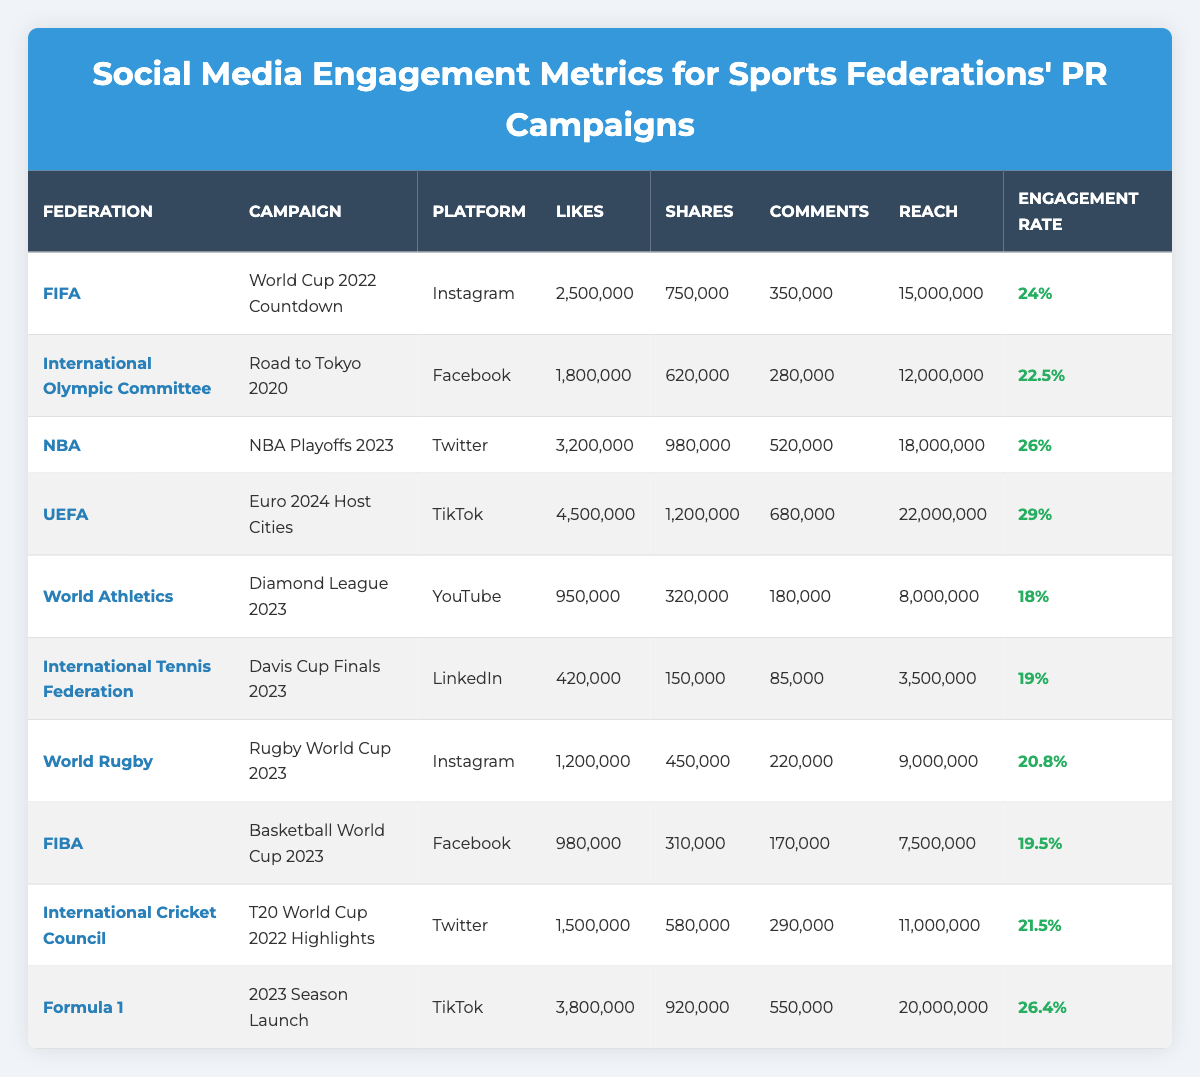What is the total number of Likes for the FIFA and NBA campaigns combined? The Likes for the FIFA campaign is 2,500,000 and for the NBA campaign it is 3,200,000. Adding these gives 2,500,000 + 3,200,000 = 5,700,000.
Answer: 5,700,000 Which platform had the highest Engagement Rate among the campaigns listed? The table shows the Engagement Rates for the campaigns; UEFA on TikTok has the highest Engagement Rate of 29%.
Answer: TikTok Did the International Tennis Federation's campaign receive more Likes or Shares? The campaign received 420,000 Likes and 150,000 Shares. Since 420,000 is greater than 150,000, it received more Likes.
Answer: More Likes What is the difference in Reach between the FIFA and World Rugby campaigns? The Reach for FIFA is 15,000,000 and for World Rugby is 9,000,000. The difference is 15,000,000 - 9,000,000 = 6,000,000.
Answer: 6,000,000 Which campaign has the most Comments, and how many Comments did it receive? The NBA Playoffs 2023 campaign received 520,000 Comments, which is the highest among all campaigns listed.
Answer: NBA Playoffs 2023, 520,000 Comments What is the average Engagement Rate for the campaigns listed in the table? The Engagement Rates are 24%, 22.5%, 26%, 29%, 18%, 19%, 20.8%, 19.5%, 21.5%, and 26.4%. Adding these gives 24 + 22.5 + 26 + 29 + 18 + 19 + 20.8 + 19.5 + 21.5 + 26.4 =  236.7, and dividing by 10 gives an average of 23.67%.
Answer: 23.67% Which sport federation had a campaign with Likes over 4 million? UEFA with the Euro 2024 Host Cities campaign had 4,500,000 Likes.
Answer: UEFA Did any campaign have an Engagement Rate lower than 20%? Yes, the World Athletics campaign had an Engagement Rate of 18%, which is lower than 20%.
Answer: Yes What is the total number of Shares across all campaigns? The Shares are: 750,000 (FIFA) + 620,000 (IOC) + 980,000 (NBA) + 1,200,000 (UEFA) + 320,000 (World Athletics) + 150,000 (ITF) + 450,000 (World Rugby) + 310,000 (FIBA) + 580,000 (ICC) + 920,000 (F1), summing these gives a total of 5,910,000.
Answer: 5,910,000 Which Federation's campaign had the highest number of Likes on TikTok? UEFA's Euro 2024 Host Cities campaign had 4,500,000 Likes on TikTok, which is the highest among those campaigns.
Answer: UEFA How many Comments did the International Cricket Council's campaign receive? The International Cricket Council's campaign received 290,000 Comments.
Answer: 290,000 